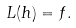Convert formula to latex. <formula><loc_0><loc_0><loc_500><loc_500>L ( h ) = f .</formula> 